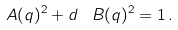<formula> <loc_0><loc_0><loc_500><loc_500>\ A ( q ) ^ { 2 } + d \, \ B ( q ) ^ { 2 } = 1 \, .</formula> 